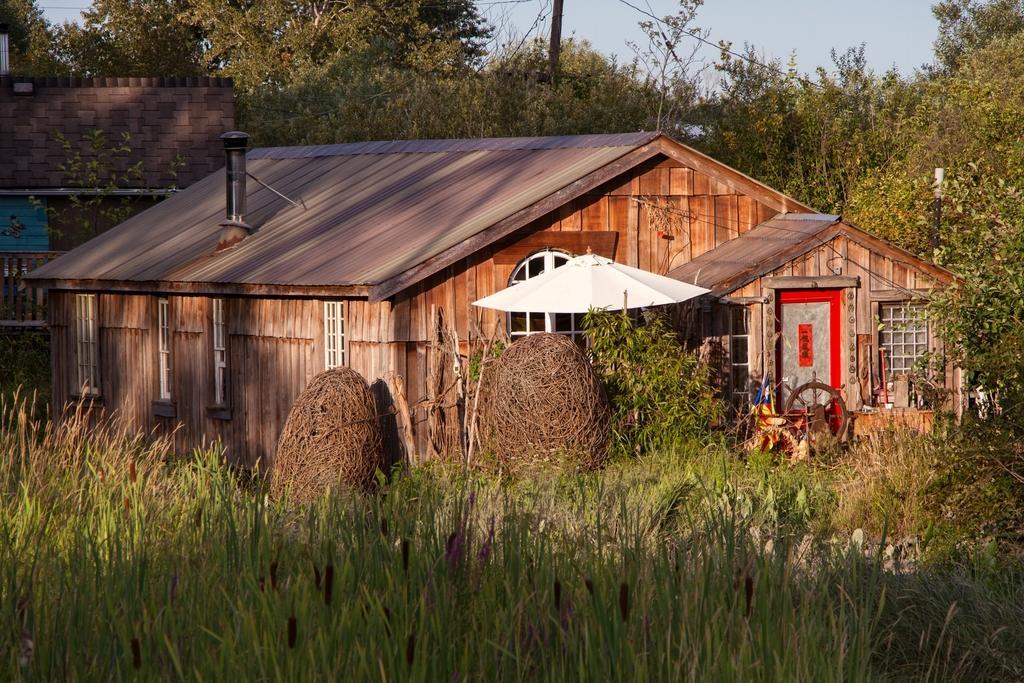How would you summarize this image in a sentence or two? In the image there is a wooden house and around the house there are plenty of trees and grass. In front of the house there is a wheel kept in front of the door. 